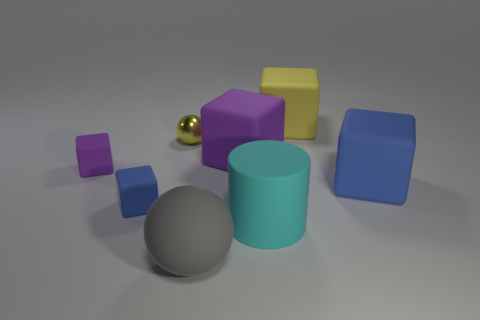Subtract 1 blocks. How many blocks are left? 4 Subtract all red cubes. Subtract all cyan cylinders. How many cubes are left? 5 Add 1 large yellow things. How many objects exist? 9 Subtract all cylinders. How many objects are left? 7 Add 8 large cyan objects. How many large cyan objects exist? 9 Subtract 1 yellow spheres. How many objects are left? 7 Subtract all shiny spheres. Subtract all cyan cylinders. How many objects are left? 6 Add 4 small metal balls. How many small metal balls are left? 5 